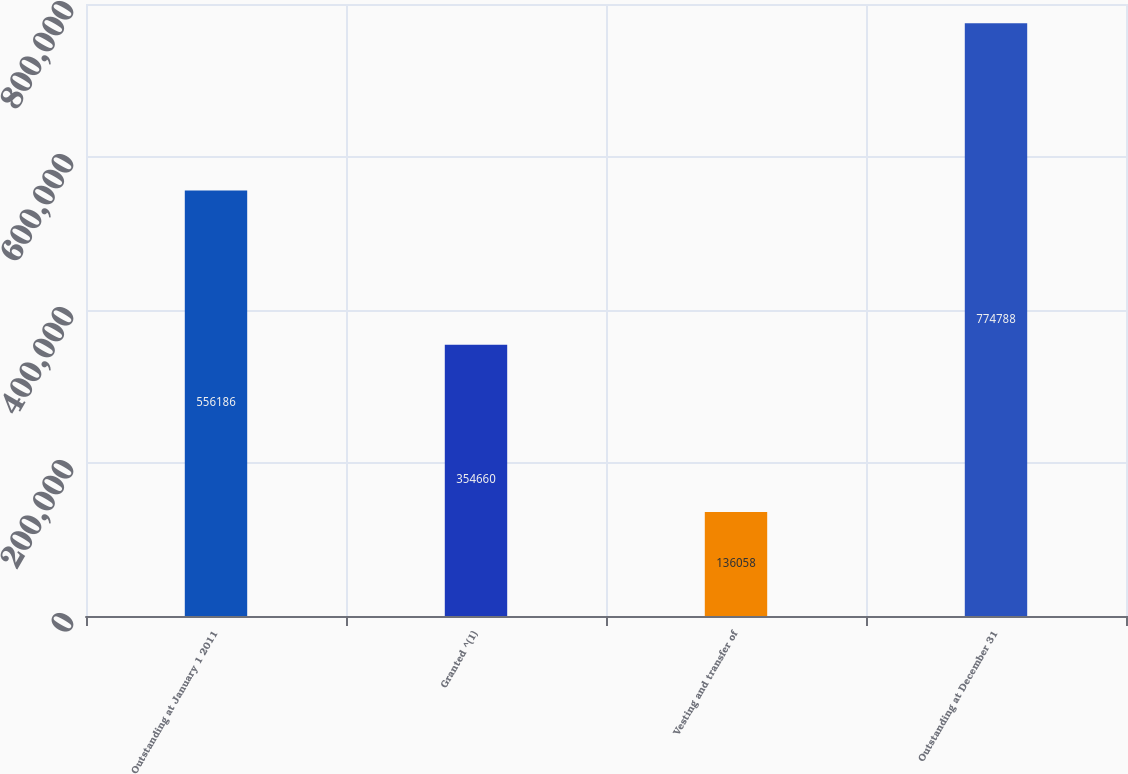Convert chart. <chart><loc_0><loc_0><loc_500><loc_500><bar_chart><fcel>Outstanding at January 1 2011<fcel>Granted ^(1)<fcel>Vesting and transfer of<fcel>Outstanding at December 31<nl><fcel>556186<fcel>354660<fcel>136058<fcel>774788<nl></chart> 